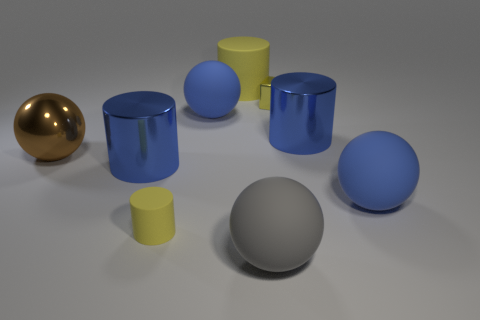Subtract all small yellow matte cylinders. How many cylinders are left? 3 Subtract all brown spheres. How many spheres are left? 3 Subtract all cylinders. How many objects are left? 5 Add 8 blue metal objects. How many blue metal objects are left? 10 Add 1 purple matte blocks. How many purple matte blocks exist? 1 Subtract 0 gray cylinders. How many objects are left? 9 Subtract 1 balls. How many balls are left? 3 Subtract all red cylinders. Subtract all blue blocks. How many cylinders are left? 4 Subtract all blue blocks. How many purple spheres are left? 0 Subtract all brown metallic spheres. Subtract all large gray matte spheres. How many objects are left? 7 